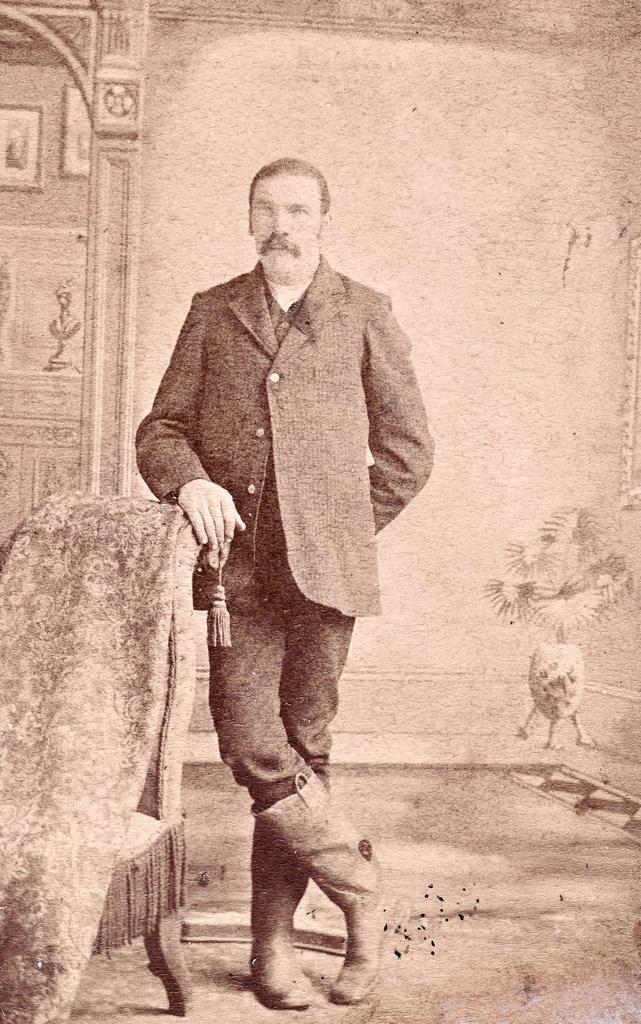How would you summarize this image in a sentence or two? It is a black and white picture. In the image in the center we can see one man standing. And on the left side of the image,we can see one sofa and blanket. In the background there is a wall,pillar,plant pot,floor and photo frames. 